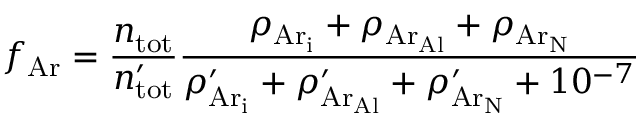<formula> <loc_0><loc_0><loc_500><loc_500>f _ { A r } = \frac { n _ { t o t } } { n _ { t o t } ^ { \prime } } \frac { \rho _ { { A r } _ { i } } + \rho _ { { A r } _ { A l } } + \rho _ { { A r } _ { N } } } { \rho _ { { A r } _ { i } } ^ { \prime } + \rho _ { { A r } _ { A l } } ^ { \prime } + \rho _ { { A r } _ { N } } ^ { \prime } + 1 0 ^ { - 7 } }</formula> 